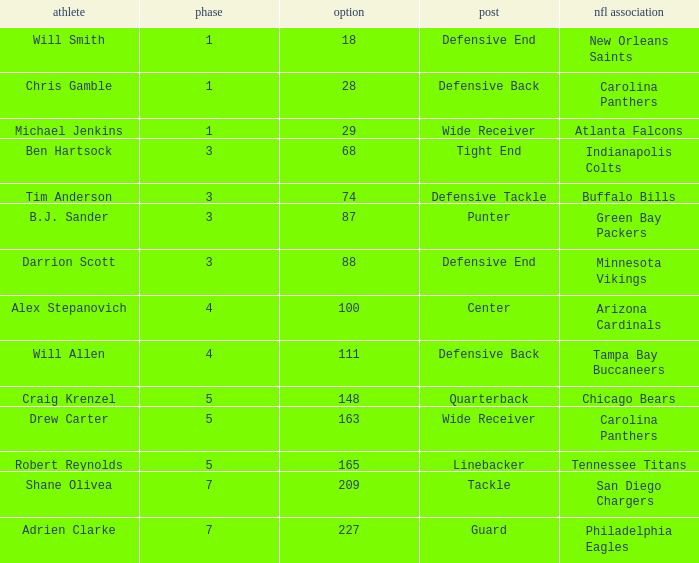What is the average Round number of Player Adrien Clarke? 7.0. 